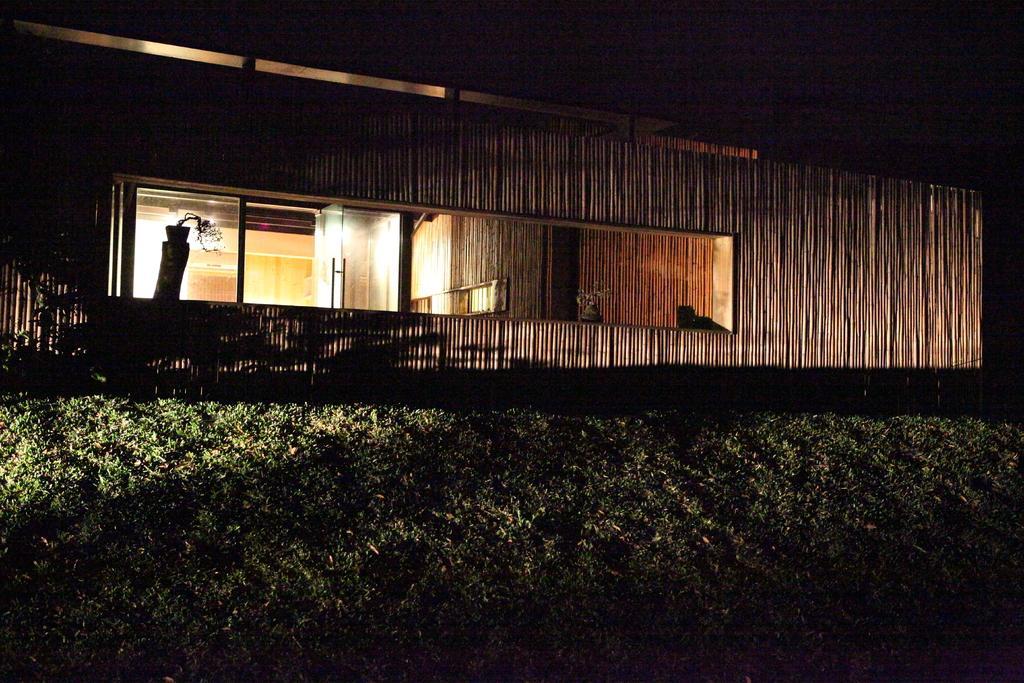Could you give a brief overview of what you see in this image? In the picture we can see plants, house, and a glass door. 